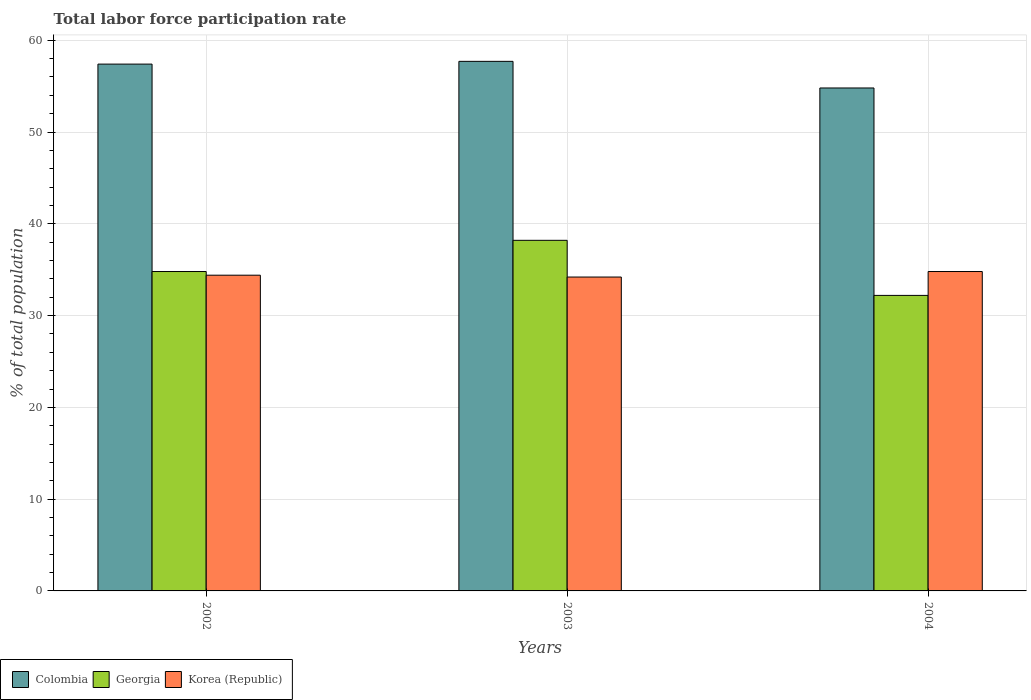Are the number of bars on each tick of the X-axis equal?
Your answer should be compact. Yes. What is the total labor force participation rate in Korea (Republic) in 2004?
Offer a very short reply. 34.8. Across all years, what is the maximum total labor force participation rate in Georgia?
Ensure brevity in your answer.  38.2. Across all years, what is the minimum total labor force participation rate in Korea (Republic)?
Give a very brief answer. 34.2. In which year was the total labor force participation rate in Korea (Republic) maximum?
Provide a short and direct response. 2004. What is the total total labor force participation rate in Georgia in the graph?
Keep it short and to the point. 105.2. What is the difference between the total labor force participation rate in Korea (Republic) in 2002 and that in 2004?
Provide a short and direct response. -0.4. What is the difference between the total labor force participation rate in Korea (Republic) in 2003 and the total labor force participation rate in Colombia in 2004?
Make the answer very short. -20.6. What is the average total labor force participation rate in Korea (Republic) per year?
Make the answer very short. 34.47. In how many years, is the total labor force participation rate in Georgia greater than 30 %?
Offer a terse response. 3. What is the ratio of the total labor force participation rate in Korea (Republic) in 2002 to that in 2004?
Your answer should be compact. 0.99. What is the difference between the highest and the second highest total labor force participation rate in Georgia?
Keep it short and to the point. 3.4. What is the difference between the highest and the lowest total labor force participation rate in Colombia?
Offer a very short reply. 2.9. What does the 2nd bar from the right in 2003 represents?
Your answer should be compact. Georgia. Is it the case that in every year, the sum of the total labor force participation rate in Colombia and total labor force participation rate in Georgia is greater than the total labor force participation rate in Korea (Republic)?
Keep it short and to the point. Yes. How many years are there in the graph?
Give a very brief answer. 3. What is the difference between two consecutive major ticks on the Y-axis?
Provide a succinct answer. 10. Are the values on the major ticks of Y-axis written in scientific E-notation?
Your answer should be very brief. No. Where does the legend appear in the graph?
Provide a short and direct response. Bottom left. How many legend labels are there?
Offer a very short reply. 3. What is the title of the graph?
Provide a short and direct response. Total labor force participation rate. Does "Swaziland" appear as one of the legend labels in the graph?
Provide a succinct answer. No. What is the label or title of the Y-axis?
Offer a very short reply. % of total population. What is the % of total population in Colombia in 2002?
Offer a terse response. 57.4. What is the % of total population of Georgia in 2002?
Your answer should be very brief. 34.8. What is the % of total population in Korea (Republic) in 2002?
Provide a short and direct response. 34.4. What is the % of total population in Colombia in 2003?
Ensure brevity in your answer.  57.7. What is the % of total population in Georgia in 2003?
Provide a succinct answer. 38.2. What is the % of total population of Korea (Republic) in 2003?
Provide a short and direct response. 34.2. What is the % of total population in Colombia in 2004?
Your response must be concise. 54.8. What is the % of total population in Georgia in 2004?
Offer a terse response. 32.2. What is the % of total population in Korea (Republic) in 2004?
Offer a terse response. 34.8. Across all years, what is the maximum % of total population in Colombia?
Offer a terse response. 57.7. Across all years, what is the maximum % of total population in Georgia?
Ensure brevity in your answer.  38.2. Across all years, what is the maximum % of total population of Korea (Republic)?
Provide a short and direct response. 34.8. Across all years, what is the minimum % of total population in Colombia?
Make the answer very short. 54.8. Across all years, what is the minimum % of total population in Georgia?
Your answer should be very brief. 32.2. Across all years, what is the minimum % of total population of Korea (Republic)?
Provide a short and direct response. 34.2. What is the total % of total population in Colombia in the graph?
Give a very brief answer. 169.9. What is the total % of total population of Georgia in the graph?
Your response must be concise. 105.2. What is the total % of total population in Korea (Republic) in the graph?
Make the answer very short. 103.4. What is the difference between the % of total population of Georgia in 2002 and that in 2003?
Make the answer very short. -3.4. What is the difference between the % of total population of Korea (Republic) in 2002 and that in 2003?
Provide a short and direct response. 0.2. What is the difference between the % of total population in Korea (Republic) in 2002 and that in 2004?
Keep it short and to the point. -0.4. What is the difference between the % of total population of Georgia in 2003 and that in 2004?
Give a very brief answer. 6. What is the difference between the % of total population of Korea (Republic) in 2003 and that in 2004?
Keep it short and to the point. -0.6. What is the difference between the % of total population in Colombia in 2002 and the % of total population in Georgia in 2003?
Make the answer very short. 19.2. What is the difference between the % of total population in Colombia in 2002 and the % of total population in Korea (Republic) in 2003?
Provide a succinct answer. 23.2. What is the difference between the % of total population of Colombia in 2002 and the % of total population of Georgia in 2004?
Offer a very short reply. 25.2. What is the difference between the % of total population in Colombia in 2002 and the % of total population in Korea (Republic) in 2004?
Offer a very short reply. 22.6. What is the difference between the % of total population in Georgia in 2002 and the % of total population in Korea (Republic) in 2004?
Provide a short and direct response. 0. What is the difference between the % of total population of Colombia in 2003 and the % of total population of Georgia in 2004?
Provide a succinct answer. 25.5. What is the difference between the % of total population in Colombia in 2003 and the % of total population in Korea (Republic) in 2004?
Your answer should be very brief. 22.9. What is the average % of total population in Colombia per year?
Your answer should be very brief. 56.63. What is the average % of total population of Georgia per year?
Offer a very short reply. 35.07. What is the average % of total population of Korea (Republic) per year?
Make the answer very short. 34.47. In the year 2002, what is the difference between the % of total population of Colombia and % of total population of Georgia?
Provide a short and direct response. 22.6. In the year 2003, what is the difference between the % of total population in Colombia and % of total population in Georgia?
Keep it short and to the point. 19.5. In the year 2003, what is the difference between the % of total population of Georgia and % of total population of Korea (Republic)?
Keep it short and to the point. 4. In the year 2004, what is the difference between the % of total population in Colombia and % of total population in Georgia?
Provide a short and direct response. 22.6. In the year 2004, what is the difference between the % of total population of Colombia and % of total population of Korea (Republic)?
Provide a succinct answer. 20. What is the ratio of the % of total population in Georgia in 2002 to that in 2003?
Make the answer very short. 0.91. What is the ratio of the % of total population of Colombia in 2002 to that in 2004?
Provide a short and direct response. 1.05. What is the ratio of the % of total population of Georgia in 2002 to that in 2004?
Keep it short and to the point. 1.08. What is the ratio of the % of total population in Colombia in 2003 to that in 2004?
Make the answer very short. 1.05. What is the ratio of the % of total population of Georgia in 2003 to that in 2004?
Ensure brevity in your answer.  1.19. What is the ratio of the % of total population in Korea (Republic) in 2003 to that in 2004?
Give a very brief answer. 0.98. What is the difference between the highest and the second highest % of total population in Colombia?
Make the answer very short. 0.3. What is the difference between the highest and the second highest % of total population of Korea (Republic)?
Offer a terse response. 0.4. 